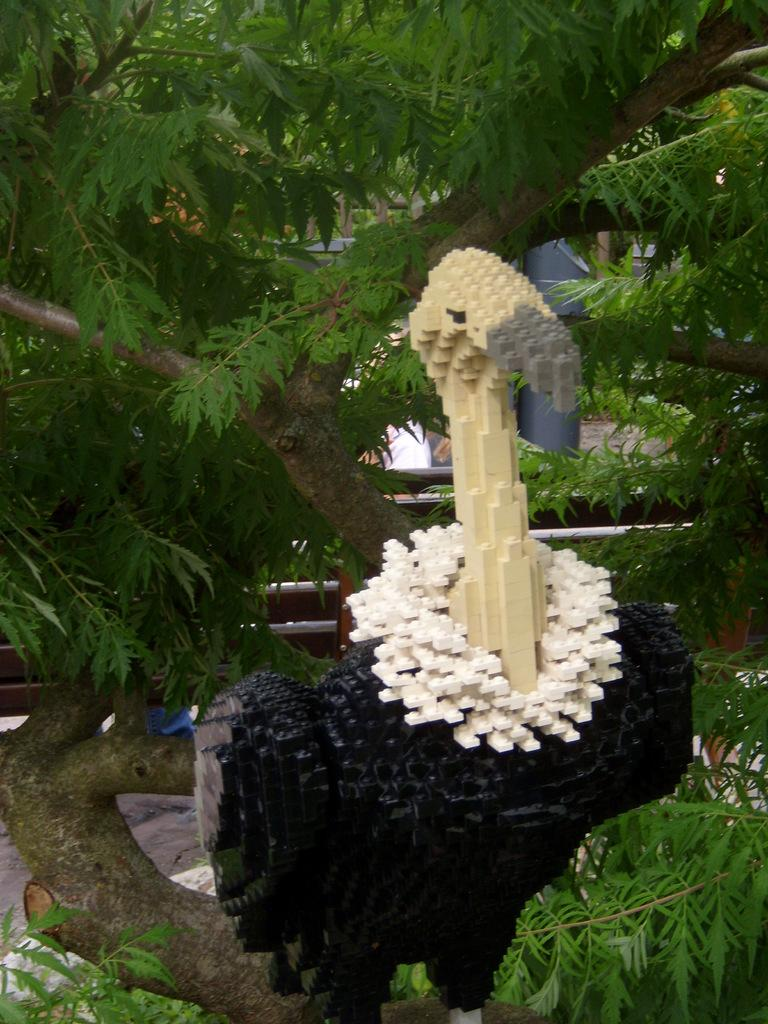What is on the tree in the image? There is a bird statue on a tree. What can be seen in the background of the image? In the background, there are branches of the tree with green leaves. What type of battle is taking place in the image? There is no battle present in the image; it features a bird statue on a tree and branches with green leaves in the background. 